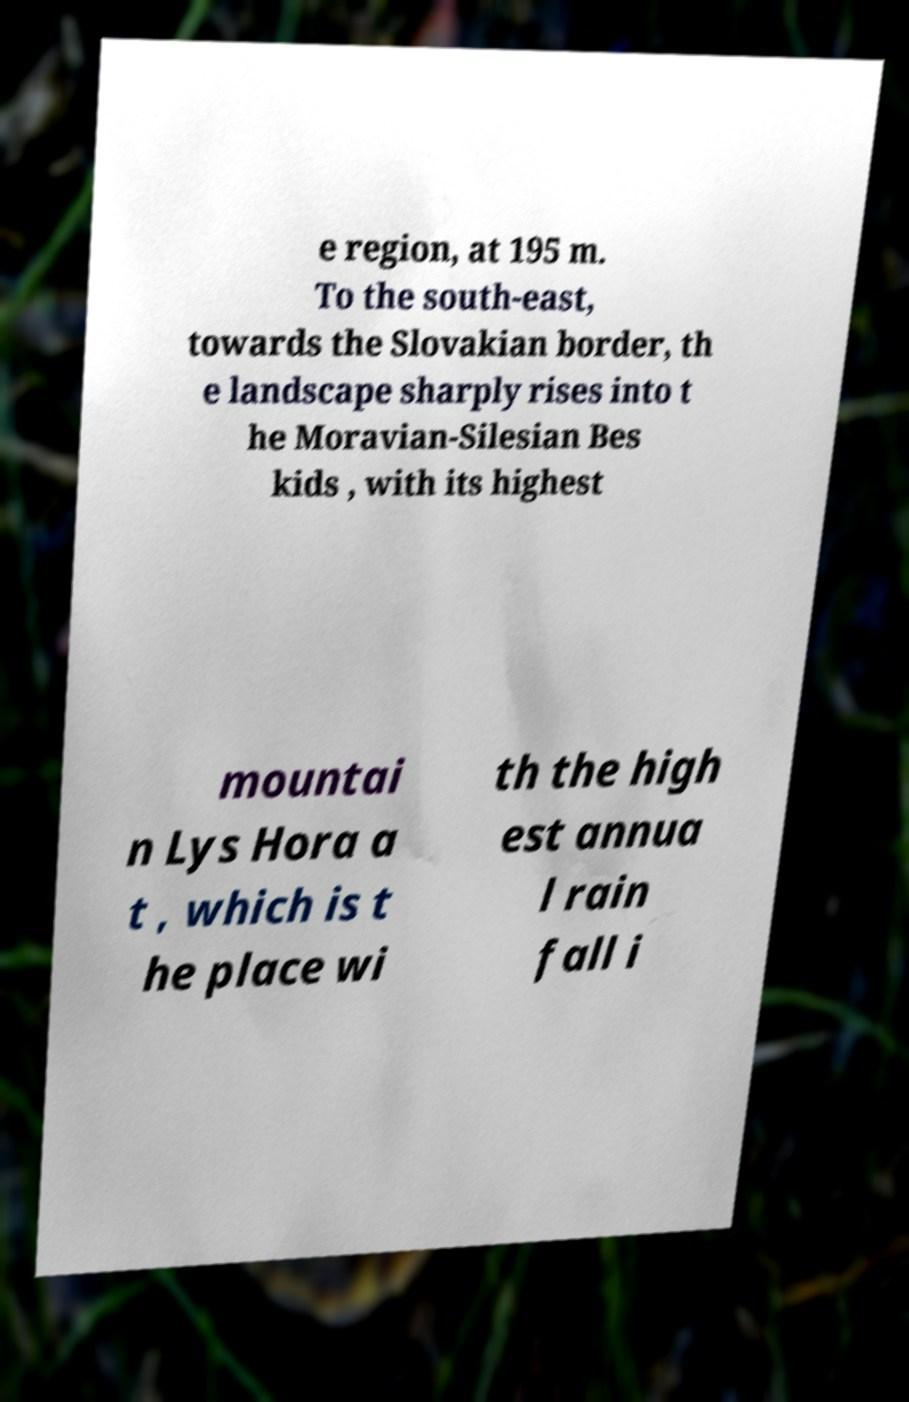I need the written content from this picture converted into text. Can you do that? e region, at 195 m. To the south-east, towards the Slovakian border, th e landscape sharply rises into t he Moravian-Silesian Bes kids , with its highest mountai n Lys Hora a t , which is t he place wi th the high est annua l rain fall i 